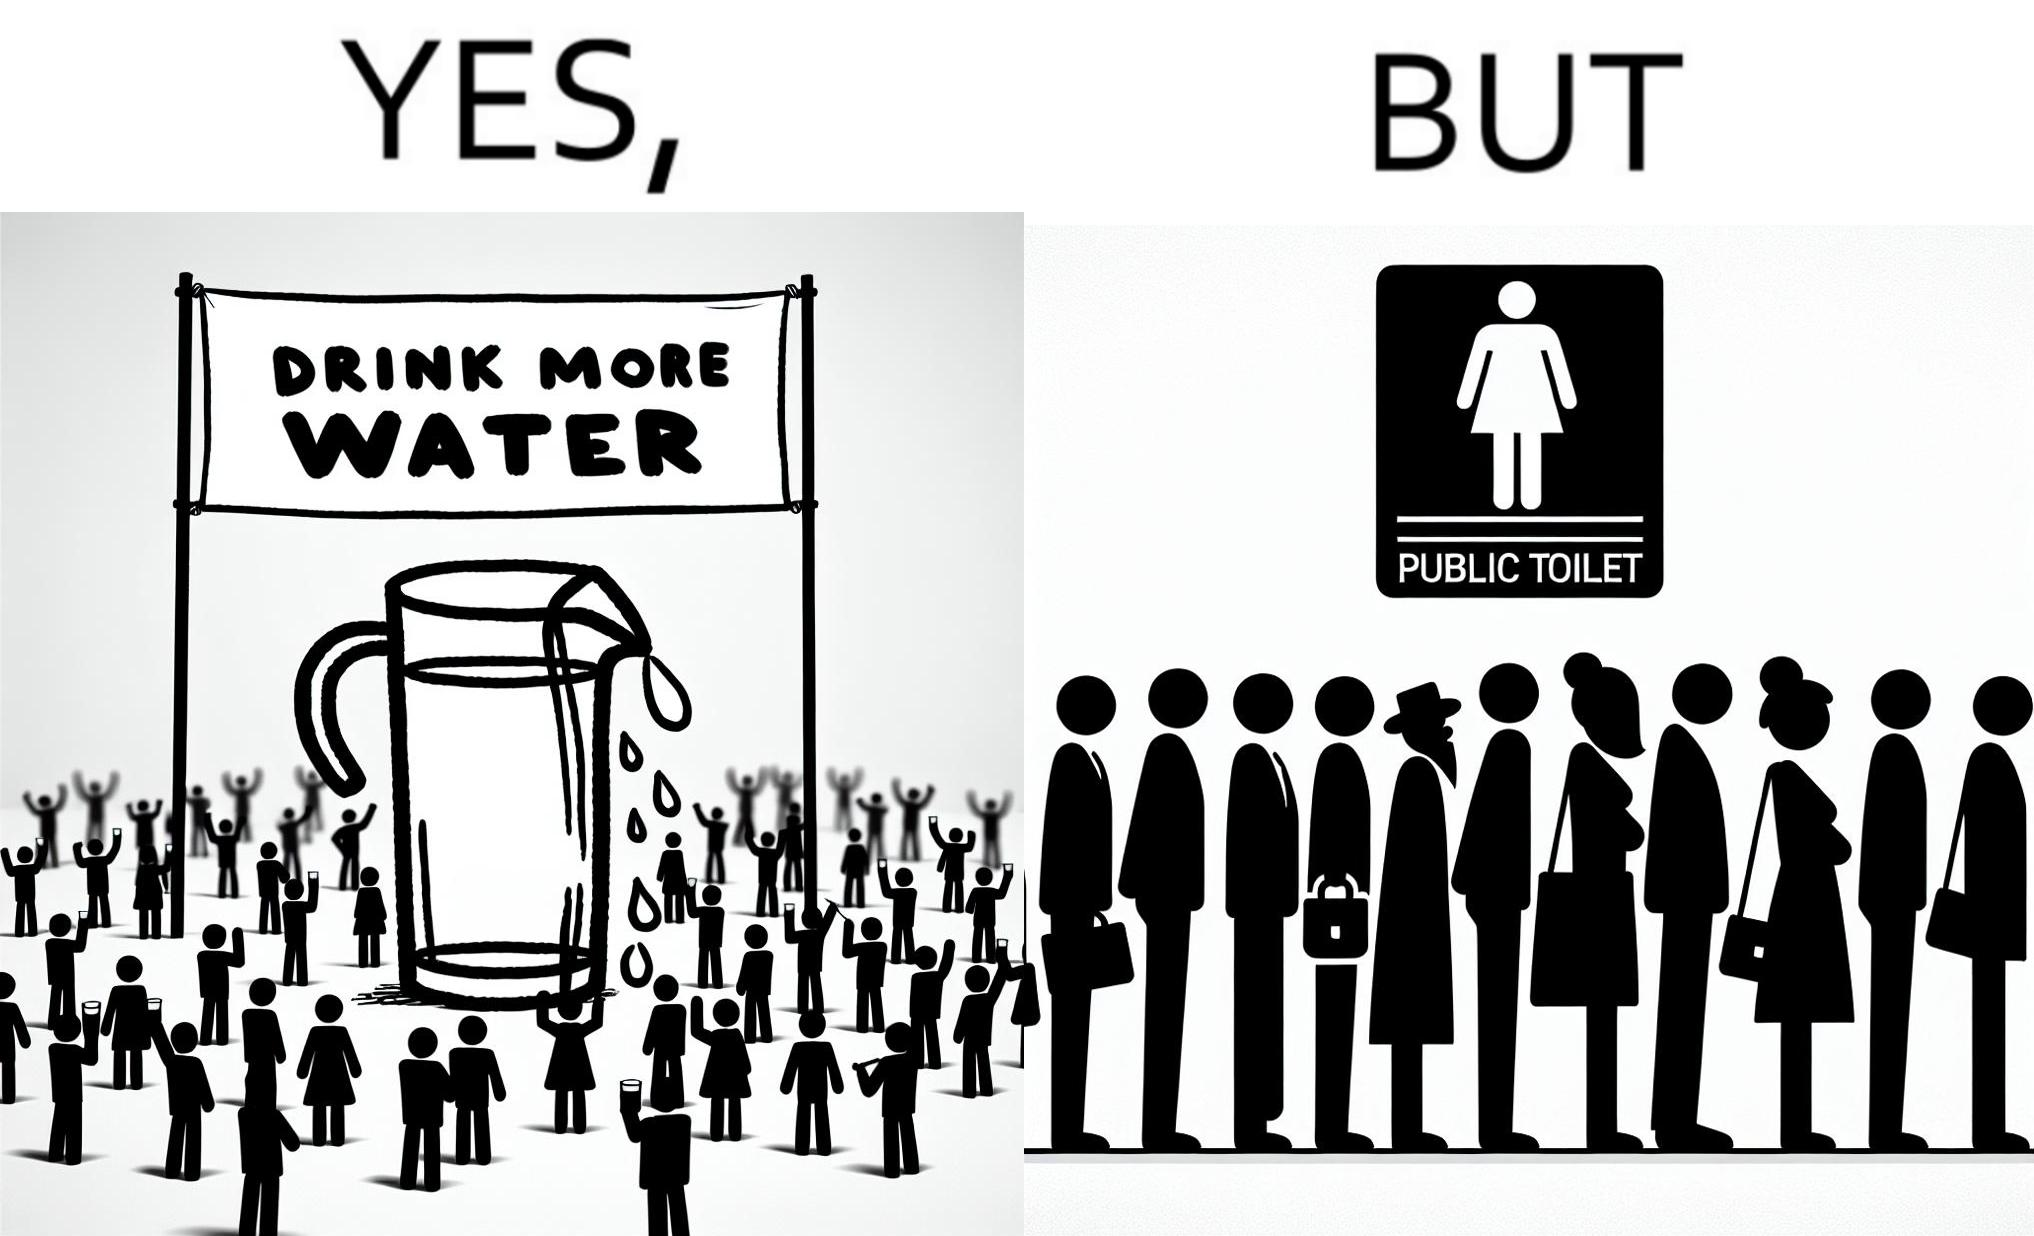Describe what you see in this image. The image is ironical, as the message "Drink more water" is meant to improve health, but in turn, it would lead to longer queues in front of public toilets, leading to people holding urine for longer periods, in turn leading to deterioration in health. 